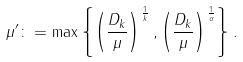<formula> <loc_0><loc_0><loc_500><loc_500>\mu ^ { \prime } \colon = \max \left \{ \left ( \frac { D _ { k } } { \mu } \right ) ^ { \frac { 1 } { k } } , \left ( \frac { D _ { k } } { \mu } \right ) ^ { \frac { 1 } { \alpha } } \right \} .</formula> 